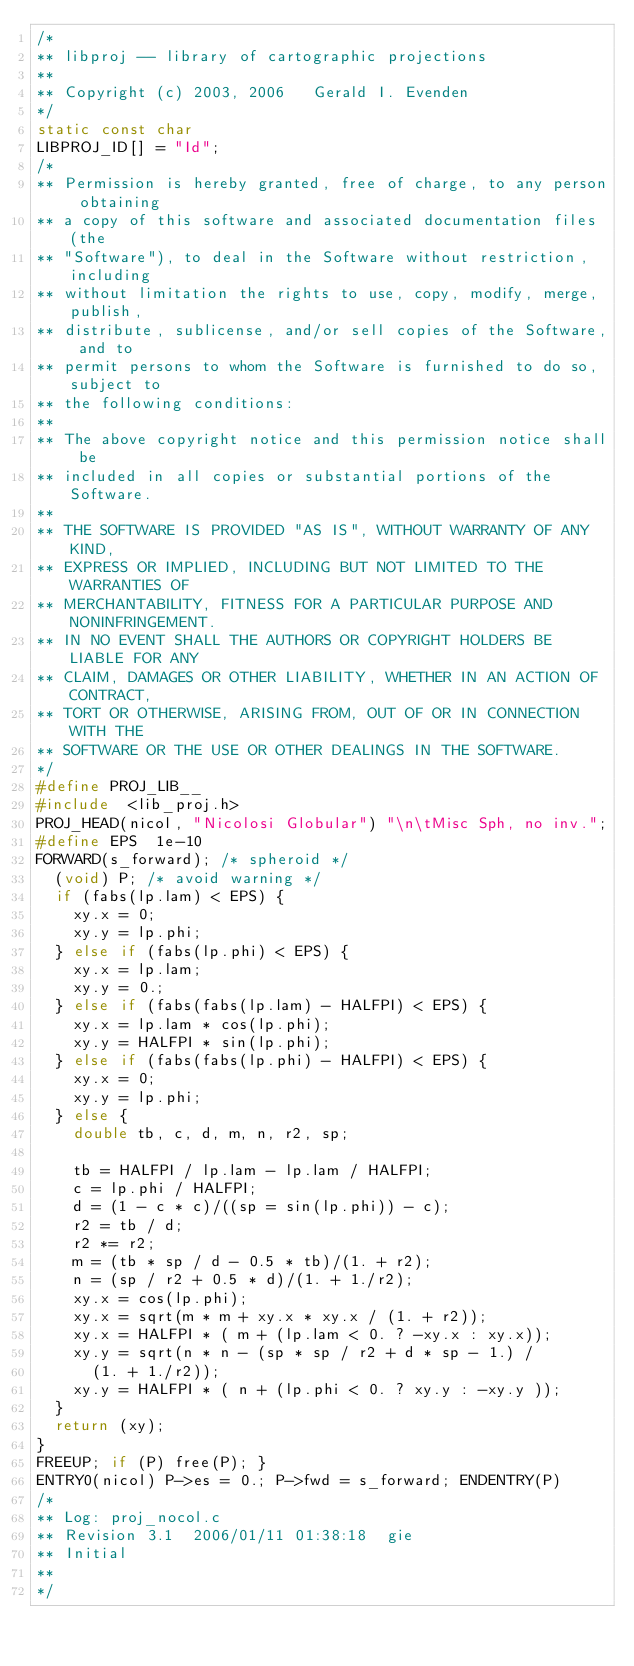<code> <loc_0><loc_0><loc_500><loc_500><_C_>/*
** libproj -- library of cartographic projections
**
** Copyright (c) 2003, 2006   Gerald I. Evenden
*/
static const char
LIBPROJ_ID[] = "Id";
/*
** Permission is hereby granted, free of charge, to any person obtaining
** a copy of this software and associated documentation files (the
** "Software"), to deal in the Software without restriction, including
** without limitation the rights to use, copy, modify, merge, publish,
** distribute, sublicense, and/or sell copies of the Software, and to
** permit persons to whom the Software is furnished to do so, subject to
** the following conditions:
**
** The above copyright notice and this permission notice shall be
** included in all copies or substantial portions of the Software.
**
** THE SOFTWARE IS PROVIDED "AS IS", WITHOUT WARRANTY OF ANY KIND,
** EXPRESS OR IMPLIED, INCLUDING BUT NOT LIMITED TO THE WARRANTIES OF
** MERCHANTABILITY, FITNESS FOR A PARTICULAR PURPOSE AND NONINFRINGEMENT.
** IN NO EVENT SHALL THE AUTHORS OR COPYRIGHT HOLDERS BE LIABLE FOR ANY
** CLAIM, DAMAGES OR OTHER LIABILITY, WHETHER IN AN ACTION OF CONTRACT,
** TORT OR OTHERWISE, ARISING FROM, OUT OF OR IN CONNECTION WITH THE
** SOFTWARE OR THE USE OR OTHER DEALINGS IN THE SOFTWARE.
*/
#define PROJ_LIB__
#include  <lib_proj.h>
PROJ_HEAD(nicol, "Nicolosi Globular") "\n\tMisc Sph, no inv.";
#define EPS  1e-10
FORWARD(s_forward); /* spheroid */
  (void) P; /* avoid warning */
  if (fabs(lp.lam) < EPS) {
    xy.x = 0;
    xy.y = lp.phi;
  } else if (fabs(lp.phi) < EPS) {
    xy.x = lp.lam;
    xy.y = 0.;
  } else if (fabs(fabs(lp.lam) - HALFPI) < EPS) {
    xy.x = lp.lam * cos(lp.phi);
    xy.y = HALFPI * sin(lp.phi);
  } else if (fabs(fabs(lp.phi) - HALFPI) < EPS) {
    xy.x = 0;
    xy.y = lp.phi;
  } else {
    double tb, c, d, m, n, r2, sp;

    tb = HALFPI / lp.lam - lp.lam / HALFPI;
    c = lp.phi / HALFPI;
    d = (1 - c * c)/((sp = sin(lp.phi)) - c);
    r2 = tb / d;
    r2 *= r2;
    m = (tb * sp / d - 0.5 * tb)/(1. + r2);
    n = (sp / r2 + 0.5 * d)/(1. + 1./r2);
    xy.x = cos(lp.phi);
    xy.x = sqrt(m * m + xy.x * xy.x / (1. + r2));
    xy.x = HALFPI * ( m + (lp.lam < 0. ? -xy.x : xy.x));
    xy.y = sqrt(n * n - (sp * sp / r2 + d * sp - 1.) /
      (1. + 1./r2));
    xy.y = HALFPI * ( n + (lp.phi < 0. ? xy.y : -xy.y ));
  }
  return (xy);
}
FREEUP; if (P) free(P); }
ENTRY0(nicol) P->es = 0.; P->fwd = s_forward; ENDENTRY(P)
/*
** Log: proj_nocol.c
** Revision 3.1  2006/01/11 01:38:18  gie
** Initial
**
*/
</code> 